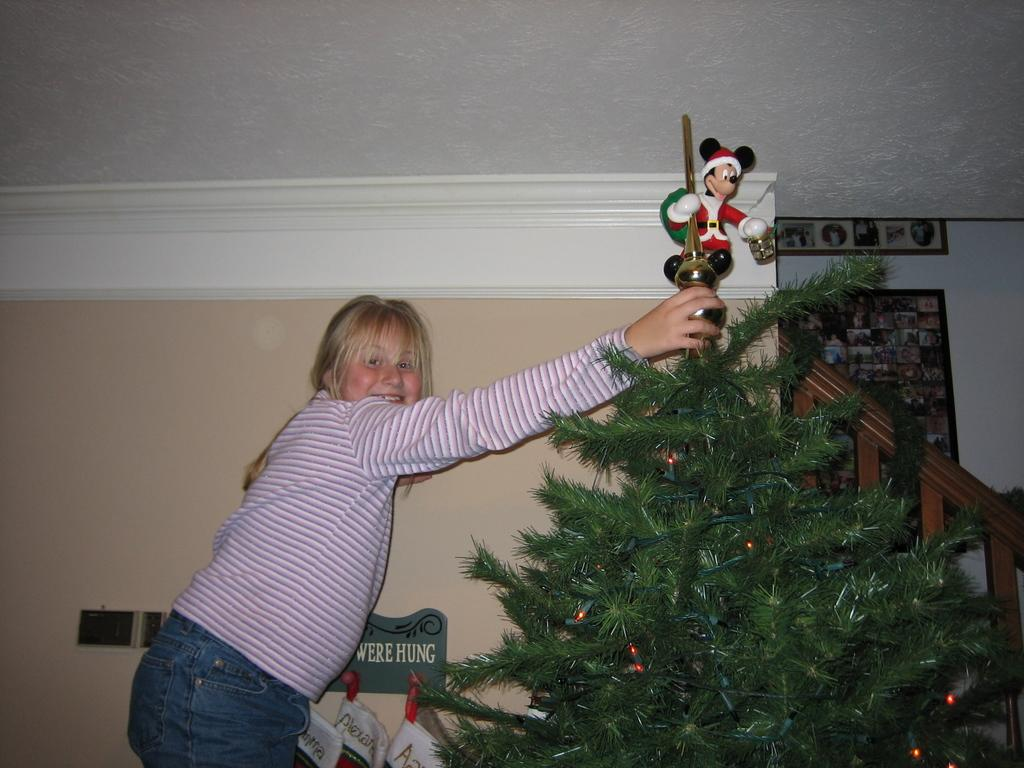Who is the main subject in the image? There is a girl in the image. What is the girl wearing? The girl is wearing a pink and white and white striped t-shirt. What is the girl holding in the image? The girl is holding a Christmas tree. What can be seen in the background of the image? There is a staircase in the background of the image. What decoration is present above the Christmas tree? There is a Mickey Mouse figure above the Christmas tree. How does the girl adjust the sail on the boat in the image? There is no boat or sail present in the image; the girl is holding a Christmas tree. 